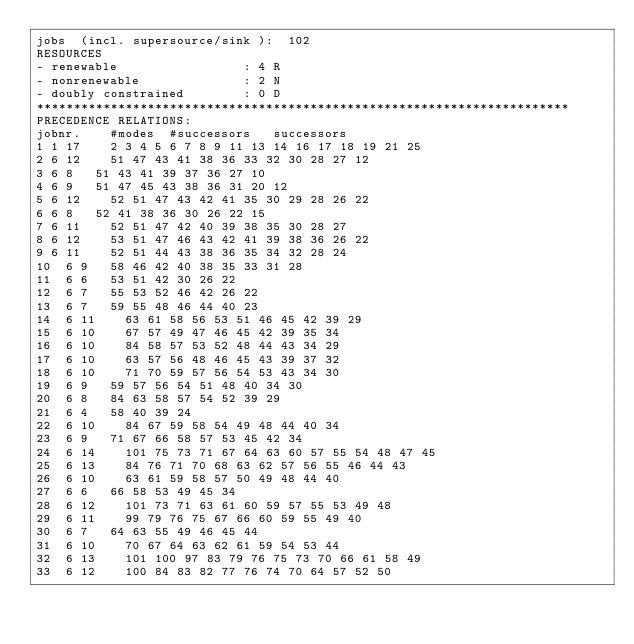<code> <loc_0><loc_0><loc_500><loc_500><_ObjectiveC_>jobs  (incl. supersource/sink ):	102
RESOURCES
- renewable                 : 4 R
- nonrenewable              : 2 N
- doubly constrained        : 0 D
************************************************************************
PRECEDENCE RELATIONS:
jobnr.    #modes  #successors   successors
1	1	17		2 3 4 5 6 7 8 9 11 13 14 16 17 18 19 21 25 
2	6	12		51 47 43 41 38 36 33 32 30 28 27 12 
3	6	8		51 43 41 39 37 36 27 10 
4	6	9		51 47 45 43 38 36 31 20 12 
5	6	12		52 51 47 43 42 41 35 30 29 28 26 22 
6	6	8		52 41 38 36 30 26 22 15 
7	6	11		52 51 47 42 40 39 38 35 30 28 27 
8	6	12		53 51 47 46 43 42 41 39 38 36 26 22 
9	6	11		52 51 44 43 38 36 35 34 32 28 24 
10	6	9		58 46 42 40 38 35 33 31 28 
11	6	6		53 51 42 30 26 22 
12	6	7		55 53 52 46 42 26 22 
13	6	7		59 55 48 46 44 40 23 
14	6	11		63 61 58 56 53 51 46 45 42 39 29 
15	6	10		67 57 49 47 46 45 42 39 35 34 
16	6	10		84 58 57 53 52 48 44 43 34 29 
17	6	10		63 57 56 48 46 45 43 39 37 32 
18	6	10		71 70 59 57 56 54 53 43 34 30 
19	6	9		59 57 56 54 51 48 40 34 30 
20	6	8		84 63 58 57 54 52 39 29 
21	6	4		58 40 39 24 
22	6	10		84 67 59 58 54 49 48 44 40 34 
23	6	9		71 67 66 58 57 53 45 42 34 
24	6	14		101 75 73 71 67 64 63 60 57 55 54 48 47 45 
25	6	13		84 76 71 70 68 63 62 57 56 55 46 44 43 
26	6	10		63 61 59 58 57 50 49 48 44 40 
27	6	6		66 58 53 49 45 34 
28	6	12		101 73 71 63 61 60 59 57 55 53 49 48 
29	6	11		99 79 76 75 67 66 60 59 55 49 40 
30	6	7		64 63 55 49 46 45 44 
31	6	10		70 67 64 63 62 61 59 54 53 44 
32	6	13		101 100 97 83 79 76 75 73 70 66 61 58 49 
33	6	12		100 84 83 82 77 76 74 70 64 57 52 50 </code> 